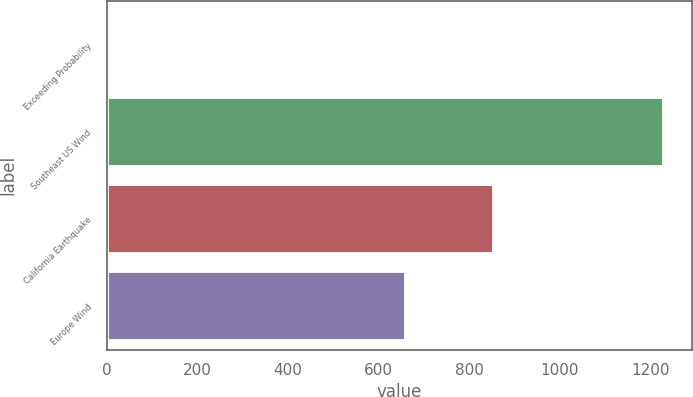<chart> <loc_0><loc_0><loc_500><loc_500><bar_chart><fcel>Exceeding Probability<fcel>Southeast US Wind<fcel>California Earthquake<fcel>Europe Wind<nl><fcel>1<fcel>1231<fcel>854<fcel>661<nl></chart> 